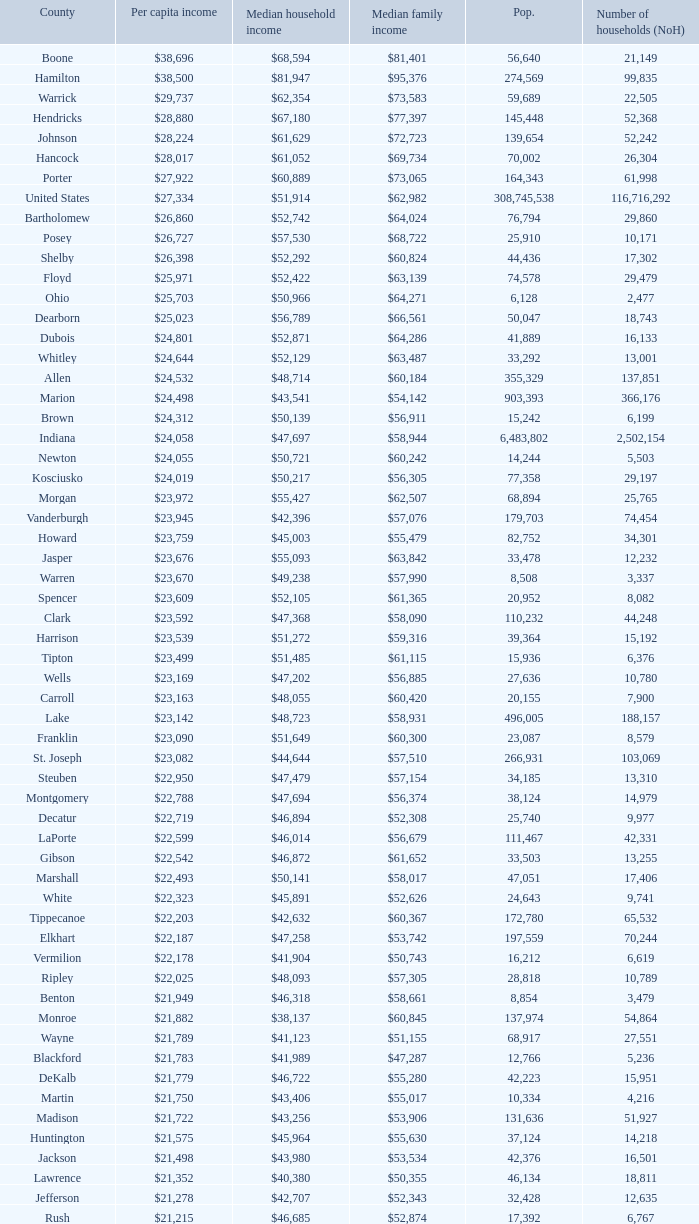What is the Median family income when the Median household income is $38,137? $60,845. 